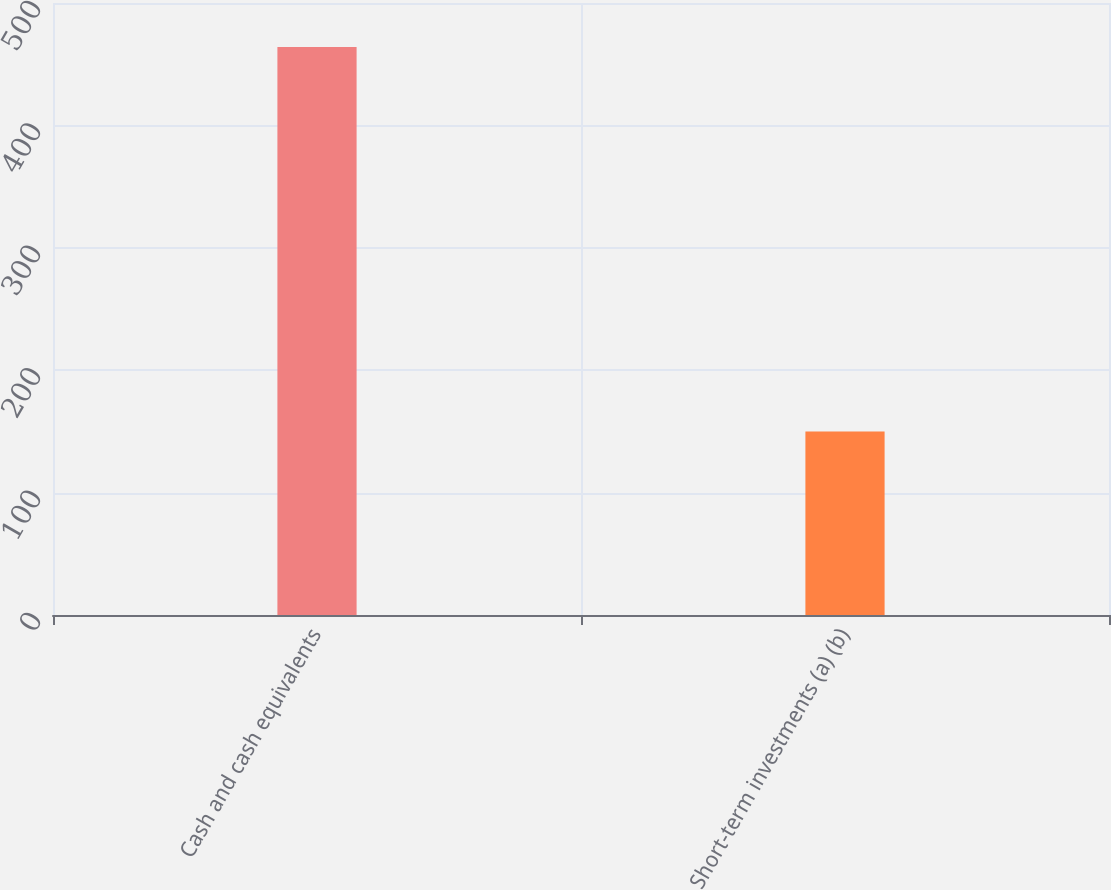Convert chart. <chart><loc_0><loc_0><loc_500><loc_500><bar_chart><fcel>Cash and cash equivalents<fcel>Short-term investments (a) (b)<nl><fcel>464<fcel>150<nl></chart> 